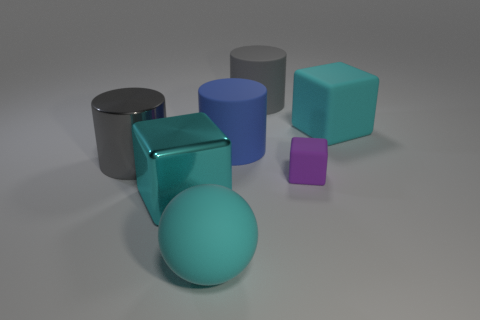Is the big matte ball the same color as the large shiny block?
Your answer should be compact. Yes. What is the material of the big gray cylinder that is in front of the cyan rubber cube?
Provide a succinct answer. Metal. What number of metal things are brown things or small purple things?
Give a very brief answer. 0. Is there a cyan object of the same size as the purple object?
Give a very brief answer. No. Is the number of large cylinders on the left side of the big gray matte thing greater than the number of matte spheres?
Give a very brief answer. Yes. What number of large things are either blocks or purple blocks?
Offer a very short reply. 2. How many large cyan objects have the same shape as the small thing?
Provide a short and direct response. 2. There is a block that is on the left side of the gray rubber thing that is behind the big blue rubber thing; what is its material?
Your response must be concise. Metal. There is a rubber block that is in front of the blue matte object; what size is it?
Ensure brevity in your answer.  Small. What number of green things are either large blocks or matte cubes?
Ensure brevity in your answer.  0. 